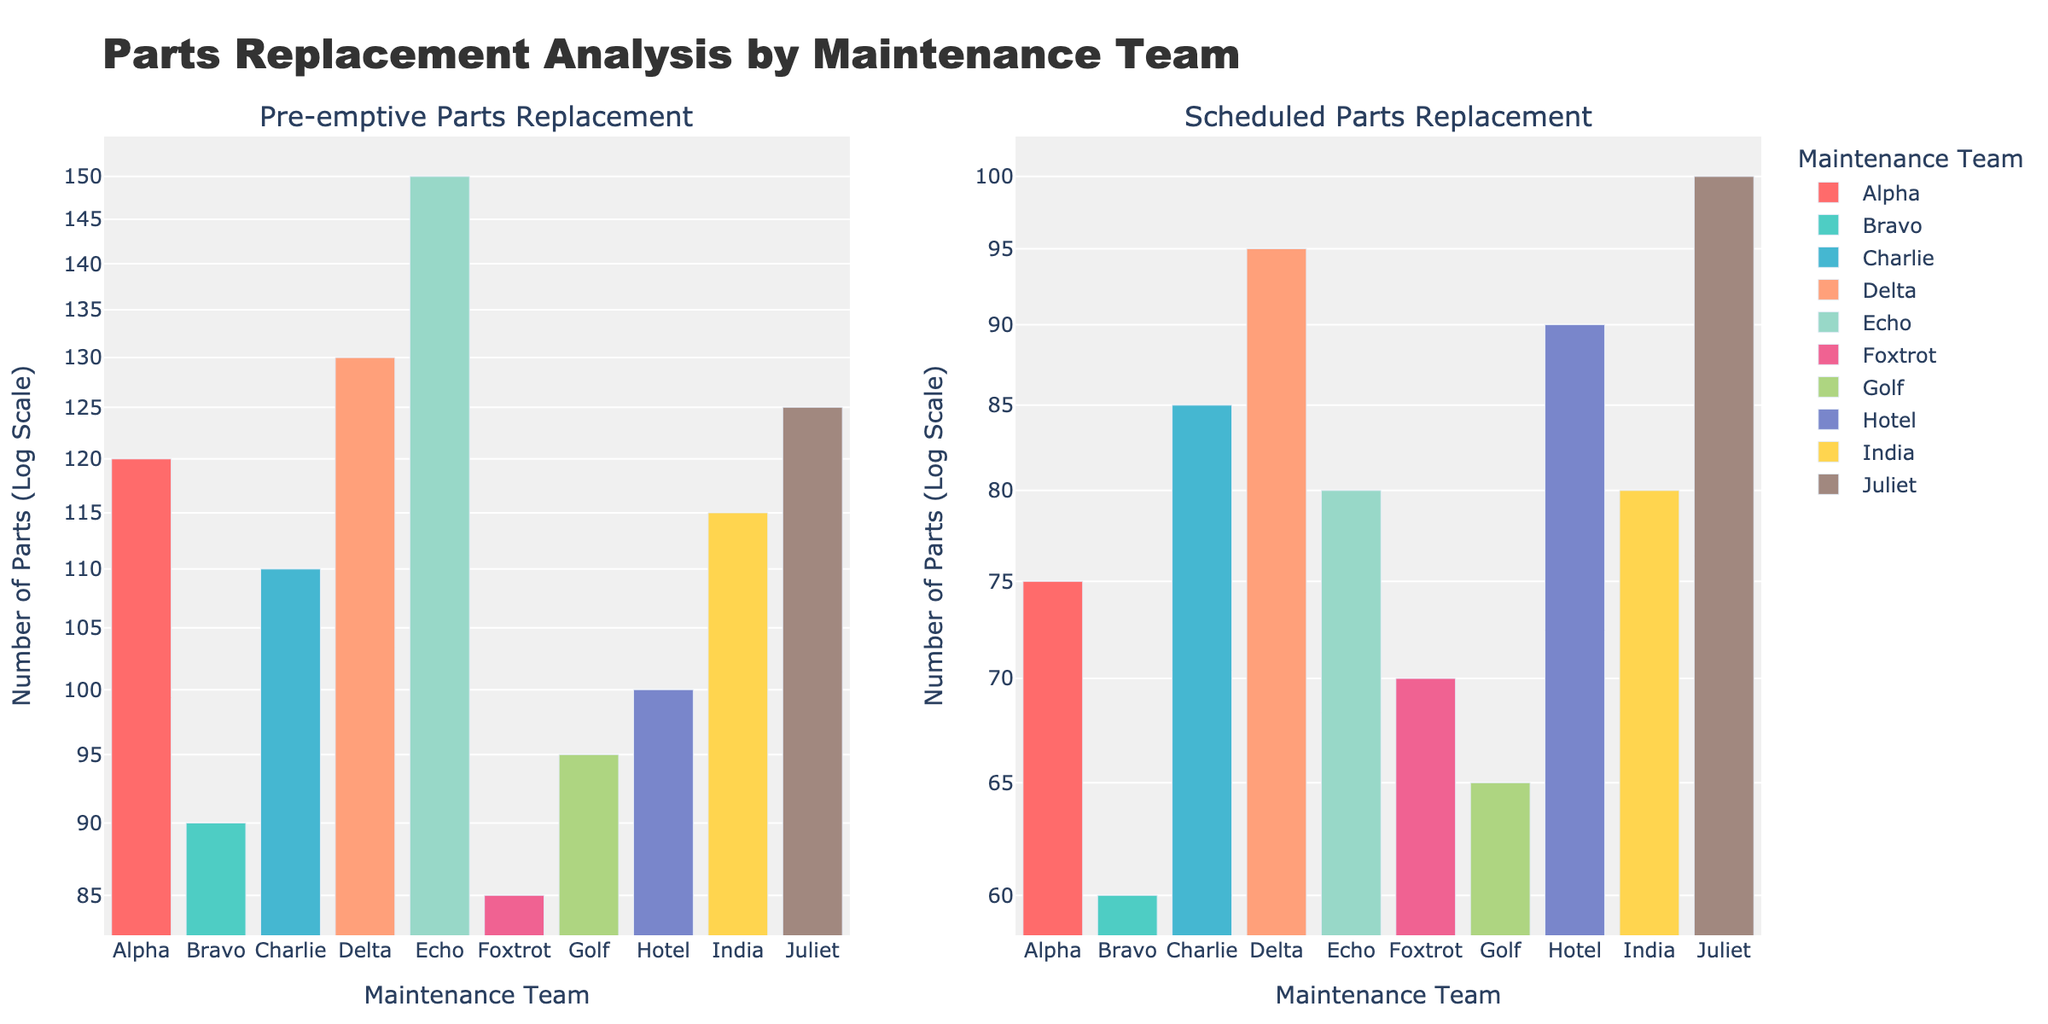Which maintenance team replaced the most parts pre-emptively? By looking at the left subplot, we identify the bar for Echo is the highest among the teams for parts replaced pre-emptively.
Answer: Echo What's the title of the figure? The title of the figure is displayed at the top of the plot.
Answer: Parts Replacement Analysis by Maintenance Team How many maintenance teams replaced between 100 and 150 parts pre-emptively? In the pre-emptive parts replacement subplot on the left, count the bars between 100 and 150 on the log scale axis. Teams Alpha, Charlie, Delta, Hotel, India, and Juliet fall within this range.
Answer: Six Which team has the least number of parts replaced during scheduled maintenance? By examining the right subplot, we see that the bar for Bravo is the shortest for the scheduled maintenance.
Answer: Bravo Which maintenance team has replaced more parts pre-emptively than scheduled? Compare each team's bar height across both subplots. Teams where the pre-emptive bar is higher than the scheduled bar are Alpha, Bravo, Charlie, Delta, Echo, Golf, and India.
Answer: Alpha, Bravo, Charlie, Delta, Echo, Golf, India What’s the total number of parts replaced pre-emptively by the Bravo, Foxtrot, and Golf teams combined? Look at the left subplot and sum the values of the bars for Bravo (90), Foxtrot (85), and Golf (95): 90 + 85 + 95 = 270.
Answer: 270 Which team shows the closest numbers of parts replaced pre-emptively and during scheduled maintenance? Examine both subplots to find the team with the smallest difference between the heights of the two bars. The bars for Hotel are closest in height.
Answer: Hotel Is the number of parts replaced pre-emptively by Delta greater than the number replaced scheduled by Echo? Check Delta's bar height in the pre-emptive subplot and compare it to Echo's bar in the scheduled subplot. Delta's pre-emptive bar indicates 130 parts, and Echo's scheduled bar indicates 80 parts, so 130 > 80.
Answer: Yes What is the combined total number of parts replaced pre-emptively and scheduled by Golf team? Add Golf's parts replaced pre-emptively (95) and scheduled (65) from both subplots: 95 + 65 = 160.
Answer: 160 Which subplot's bars have more variability in their heights, pre-emptive or scheduled? Comparing the range of bar heights, the pre-emptive subplot shows a wider range of heights (from 85 to 150) compared to the scheduled subplot (from 60 to 100).
Answer: Pre-emptive 